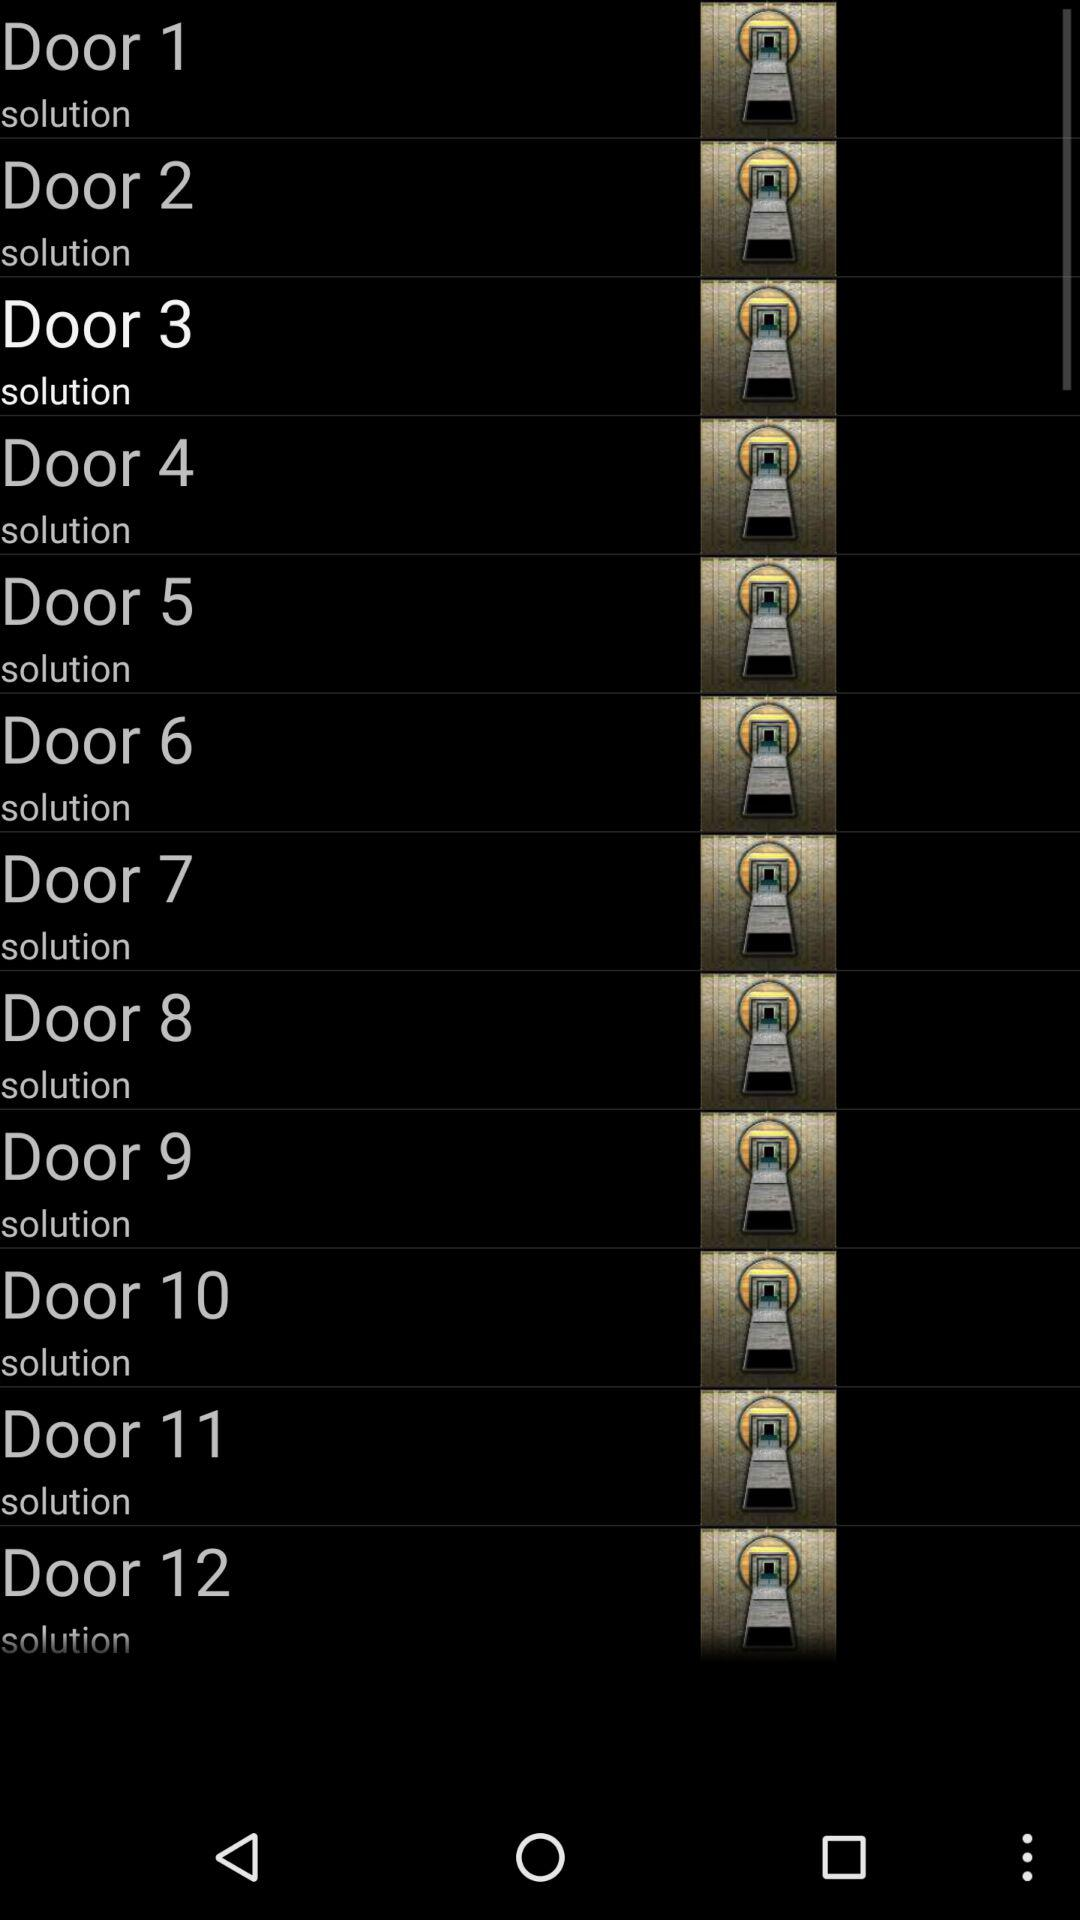How many doors are depicted with a circle around the keyhole?
Answer the question using a single word or phrase. 12 